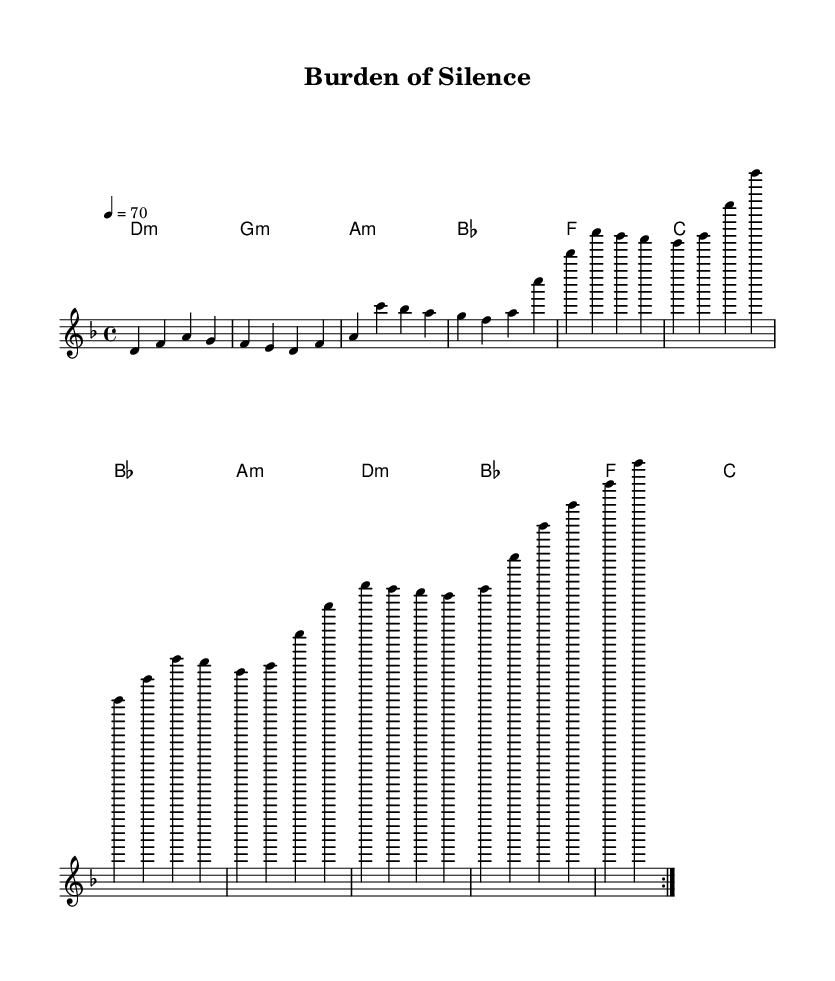What is the key signature of this music? The key signature indicated in the piece shows two flats, which corresponds to the key of D minor.
Answer: D minor What is the time signature of this piece? The time signature is specified as 4/4, meaning there are four beats in a measure, and the quarter note gets one beat.
Answer: 4/4 What is the tempo marking of this music? The tempo marking indicates a speed of 70 beats per minute, which suggests a slow and relaxed pace typical of R&B songs.
Answer: 70 How many measures are in the verse section? By analyzing the melody, the verse is repeated twice, and the notated music indicates that each repetition contains four measures. Since it repeats, there are a total of 8 measures in the verse section.
Answer: 8 What type of chords are predominantly used in this piece? The harmonies provided in the score show that minor chords are predominantly used, which is characteristic of the emotional depth and introspective quality found in R&B music.
Answer: Minor What is the relationship between the pre-chorus and the chorus in terms of key? The pre-chorus ends on an A minor chord and transitions to a D minor chord at the beginning of the chorus, showing a movement between related minor chords which enhances the emotional intensity.
Answer: Related minor chords What phrase describes the overall emotional theme conveyed in this composition? The sheet music, along with its introspective lyrics and harmonies, conveys themes of inner conflict and the burden of keeping secrets, a common subject in deep, introspective R&B songs.
Answer: Inner conflict and burden of secrets 